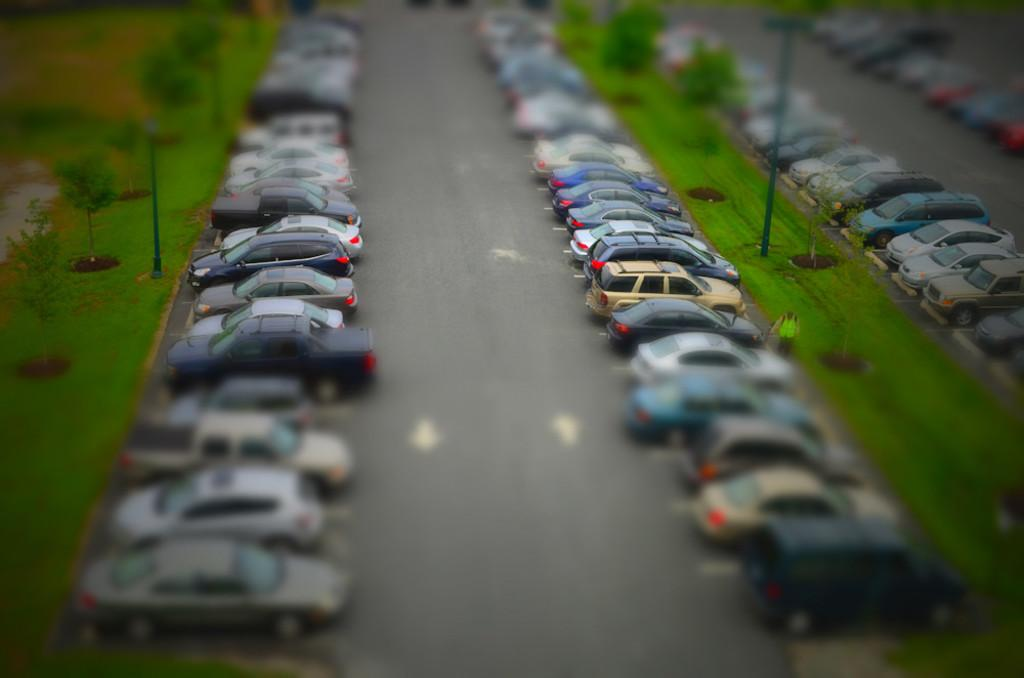What type of vehicles can be seen on the road in the image? There are cars on the road in the image. What structures are present in the image? There are poles in the image. What type of vegetation is visible in the image? There are plants and grass in the image. Is there a person in the image? Yes, there is a person in the image. What shape is the person offering in the image? There is no indication of the person offering anything in the image, and no shape can be determined. What type of error is present in the image? There is no error present in the image; it appears to be a clear and accurate representation of the scene. 